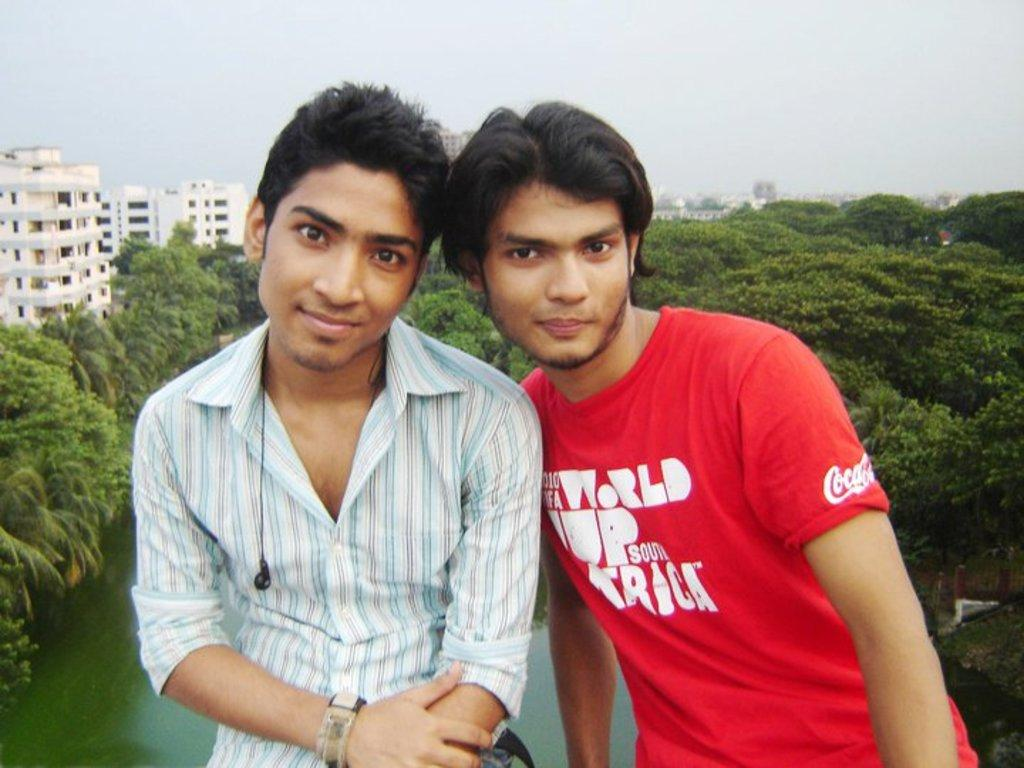What is the main subject in the center of the image? There are men in the center of the image. What can be seen in the background of the image? There are buildings, water, trees, and the sky visible in the background of the image. What is the profit made by the farmer in the image? There is no farmer or mention of profit in the image. 